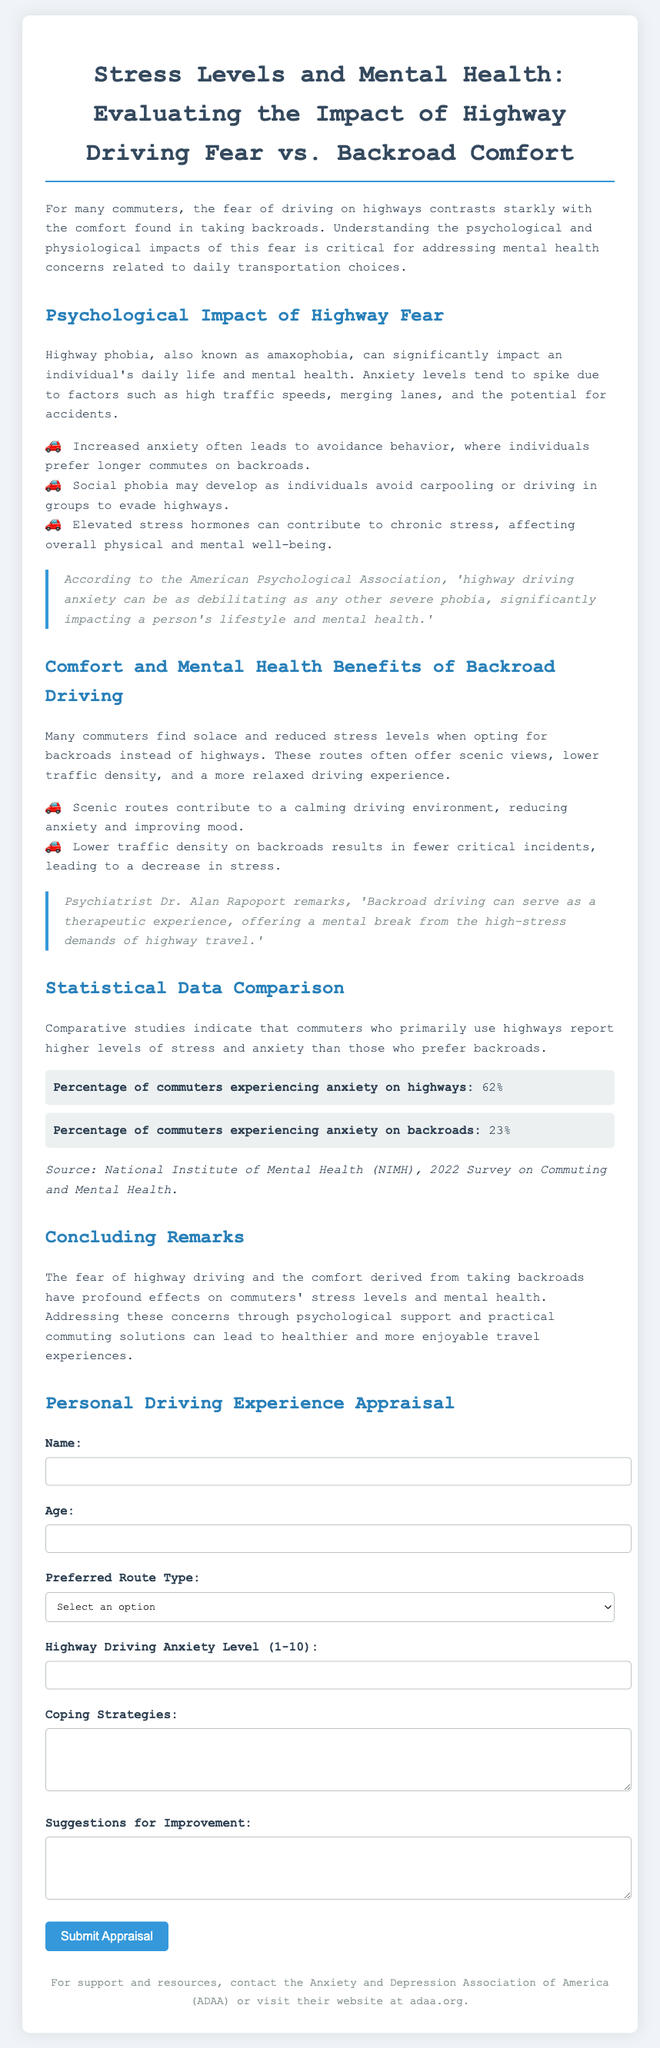What is the percentage of commuters experiencing anxiety on highways? The document states that 62% of commuters experience anxiety on highways.
Answer: 62% What is the percentage of commuters experiencing anxiety on backroads? The document indicates that 23% of commuters experience anxiety on backroads.
Answer: 23% What is amaxophobia? Amaxophobia is described in the document as highway phobia.
Answer: highway phobia Who mentioned that backroad driving can serve as a therapeutic experience? The document quotes psychiatrist Dr. Alan Rapoport regarding the therapeutic nature of backroad driving.
Answer: Dr. Alan Rapoport What is the required minimum anxiety level rating? The document specifies that the minimum anxiety level rating is 1.
Answer: 1 What type of route do individuals who experience social phobia tend to avoid? According to the document, individuals with social phobia may avoid highways.
Answer: highways What is one benefit of taking backroads mentioned in the document? The document notes that backroads often offer a more relaxed driving experience.
Answer: more relaxed driving experience What should you do if you need support and resources? The document suggests contacting the Anxiety and Depression Association of America.
Answer: contact ADAA 